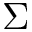Convert formula to latex. <formula><loc_0><loc_0><loc_500><loc_500>\Sigma</formula> 